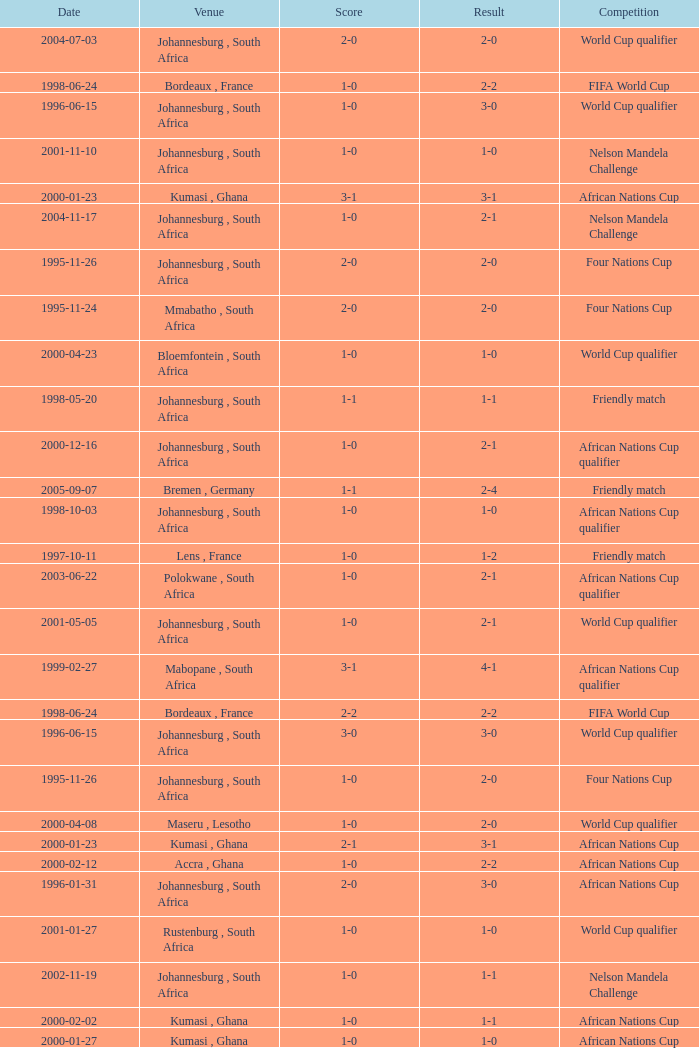What is the Date of the Fifa World Cup with a Score of 1-0? 1998-06-24. Parse the table in full. {'header': ['Date', 'Venue', 'Score', 'Result', 'Competition'], 'rows': [['2004-07-03', 'Johannesburg , South Africa', '2-0', '2-0', 'World Cup qualifier'], ['1998-06-24', 'Bordeaux , France', '1-0', '2-2', 'FIFA World Cup'], ['1996-06-15', 'Johannesburg , South Africa', '1-0', '3-0', 'World Cup qualifier'], ['2001-11-10', 'Johannesburg , South Africa', '1-0', '1-0', 'Nelson Mandela Challenge'], ['2000-01-23', 'Kumasi , Ghana', '3-1', '3-1', 'African Nations Cup'], ['2004-11-17', 'Johannesburg , South Africa', '1-0', '2-1', 'Nelson Mandela Challenge'], ['1995-11-26', 'Johannesburg , South Africa', '2-0', '2-0', 'Four Nations Cup'], ['1995-11-24', 'Mmabatho , South Africa', '2-0', '2-0', 'Four Nations Cup'], ['2000-04-23', 'Bloemfontein , South Africa', '1-0', '1-0', 'World Cup qualifier'], ['1998-05-20', 'Johannesburg , South Africa', '1-1', '1-1', 'Friendly match'], ['2000-12-16', 'Johannesburg , South Africa', '1-0', '2-1', 'African Nations Cup qualifier'], ['2005-09-07', 'Bremen , Germany', '1-1', '2-4', 'Friendly match'], ['1998-10-03', 'Johannesburg , South Africa', '1-0', '1-0', 'African Nations Cup qualifier'], ['1997-10-11', 'Lens , France', '1-0', '1-2', 'Friendly match'], ['2003-06-22', 'Polokwane , South Africa', '1-0', '2-1', 'African Nations Cup qualifier'], ['2001-05-05', 'Johannesburg , South Africa', '1-0', '2-1', 'World Cup qualifier'], ['1999-02-27', 'Mabopane , South Africa', '3-1', '4-1', 'African Nations Cup qualifier'], ['1998-06-24', 'Bordeaux , France', '2-2', '2-2', 'FIFA World Cup'], ['1996-06-15', 'Johannesburg , South Africa', '3-0', '3-0', 'World Cup qualifier'], ['1995-11-26', 'Johannesburg , South Africa', '1-0', '2-0', 'Four Nations Cup'], ['2000-04-08', 'Maseru , Lesotho', '1-0', '2-0', 'World Cup qualifier'], ['2000-01-23', 'Kumasi , Ghana', '2-1', '3-1', 'African Nations Cup'], ['2000-02-12', 'Accra , Ghana', '1-0', '2-2', 'African Nations Cup'], ['1996-01-31', 'Johannesburg , South Africa', '2-0', '3-0', 'African Nations Cup'], ['2001-01-27', 'Rustenburg , South Africa', '1-0', '1-0', 'World Cup qualifier'], ['2002-11-19', 'Johannesburg , South Africa', '1-0', '1-1', 'Nelson Mandela Challenge'], ['2000-02-02', 'Kumasi , Ghana', '1-0', '1-1', 'African Nations Cup'], ['2000-01-27', 'Kumasi , Ghana', '1-0', '1-0', 'African Nations Cup']]} 